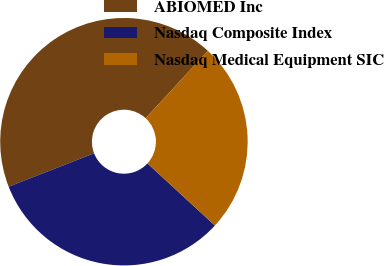Convert chart to OTSL. <chart><loc_0><loc_0><loc_500><loc_500><pie_chart><fcel>ABIOMED Inc<fcel>Nasdaq Composite Index<fcel>Nasdaq Medical Equipment SIC<nl><fcel>42.8%<fcel>32.23%<fcel>24.97%<nl></chart> 